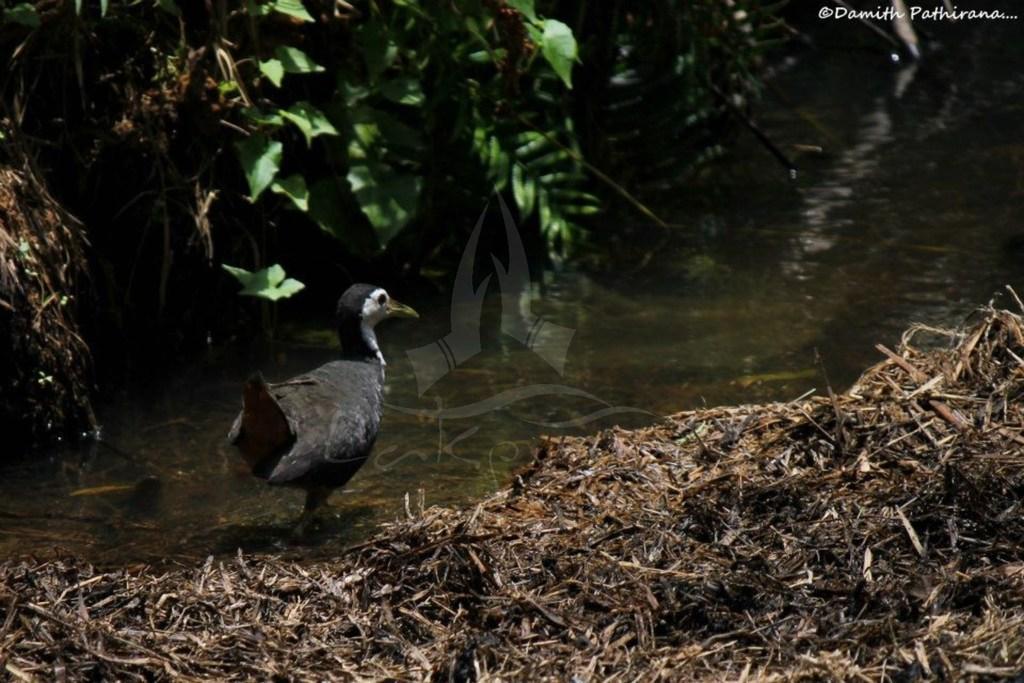Could you give a brief overview of what you see in this image? In this image we can see a bird on the surface of water. At the right bottom of the image, dry grass is there. At the top of the image leave are there. 